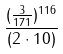Convert formula to latex. <formula><loc_0><loc_0><loc_500><loc_500>\frac { ( \frac { 3 } { 1 7 1 } ) ^ { 1 1 6 } } { ( 2 \cdot 1 0 ) }</formula> 